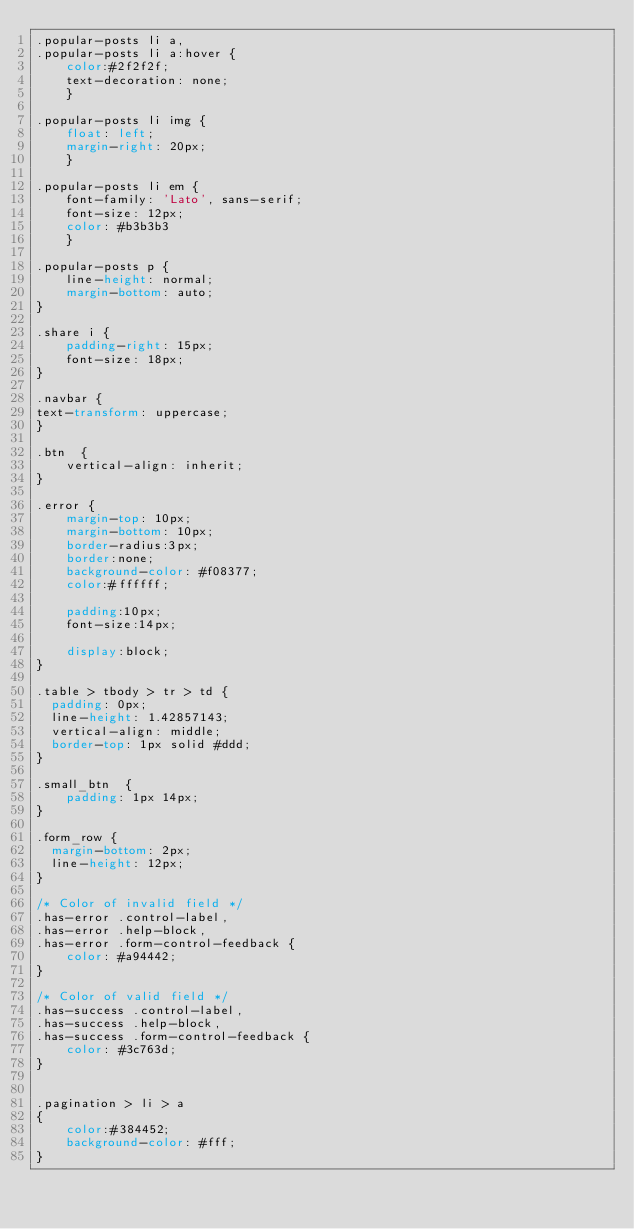<code> <loc_0><loc_0><loc_500><loc_500><_CSS_>.popular-posts li a, 
.popular-posts li a:hover {
	color:#2f2f2f; 
	text-decoration: none;
	}
	
.popular-posts li img {
	float: left; 
	margin-right: 20px;
	}
	
.popular-posts li em {
	font-family: 'Lato', sans-serif;
	font-size: 12px;
	color: #b3b3b3
	}

.popular-posts p {
	line-height: normal;
	margin-bottom: auto;
}	

.share i {
	padding-right: 15px;
	font-size: 18px;
}

.navbar {
text-transform: uppercase;
}

.btn  {
	vertical-align: inherit;
}

.error {
	margin-top: 10px;
	margin-bottom: 10px;
	border-radius:3px;
	border:none;
	background-color: #f08377;
	color:#ffffff;
	
	padding:10px;
	font-size:14px;
	
	display:block;
}

.table > tbody > tr > td {
  padding: 0px;
  line-height: 1.42857143;
  vertical-align: middle;
  border-top: 1px solid #ddd;
}

.small_btn  {
	padding: 1px 14px;
}

.form_row {
  margin-bottom: 2px;
  line-height: 12px;
}

/* Color of invalid field */
.has-error .control-label,
.has-error .help-block,
.has-error .form-control-feedback {
    color: #a94442;
}

/* Color of valid field */
.has-success .control-label,
.has-success .help-block,
.has-success .form-control-feedback {
    color: #3c763d;
}


.pagination > li > a 
{
	color:#384452;
    background-color: #fff;
}
</code> 